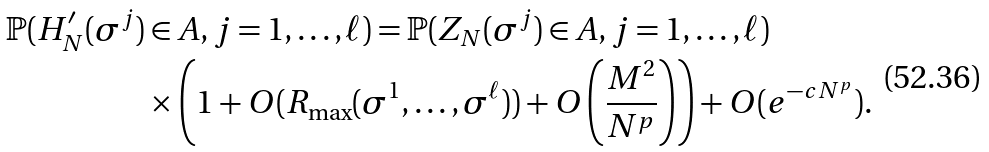<formula> <loc_0><loc_0><loc_500><loc_500>\mathbb { P } ( H ^ { \prime } _ { N } ( \sigma ^ { j } ) & \in A , j = 1 , \dots , \ell ) = \mathbb { P } ( Z _ { N } ( \sigma ^ { j } ) \in A , j = 1 , \dots , \ell ) \\ & \times \left ( 1 + O ( R _ { \max } ( \sigma ^ { 1 } , \dots , \sigma ^ { \ell } ) ) + O \left ( \frac { M ^ { 2 } } { N ^ { p } } \right ) \right ) + O ( e ^ { - c N ^ { p } } ) .</formula> 